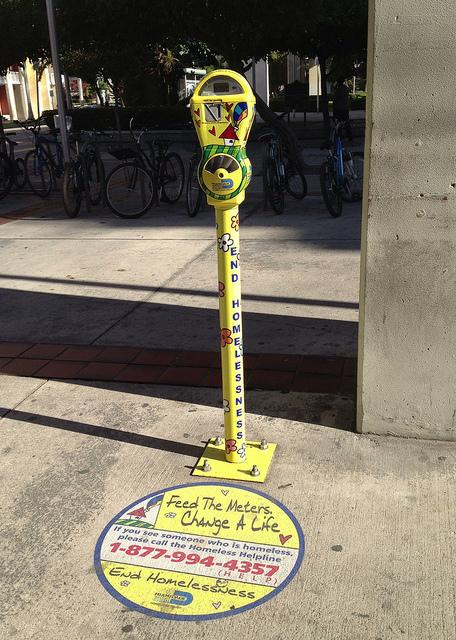What are they hoping to collect? Please explain your reasoning. coins. The sign needs coins. 